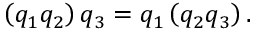Convert formula to latex. <formula><loc_0><loc_0><loc_500><loc_500>\left ( q _ { 1 } q _ { 2 } \right ) q _ { 3 } = q _ { 1 } \left ( q _ { 2 } q _ { 3 } \right ) .</formula> 